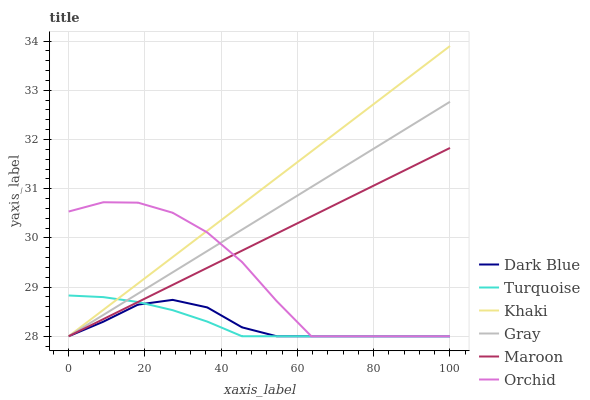Does Dark Blue have the minimum area under the curve?
Answer yes or no. Yes. Does Khaki have the maximum area under the curve?
Answer yes or no. Yes. Does Turquoise have the minimum area under the curve?
Answer yes or no. No. Does Turquoise have the maximum area under the curve?
Answer yes or no. No. Is Gray the smoothest?
Answer yes or no. Yes. Is Orchid the roughest?
Answer yes or no. Yes. Is Turquoise the smoothest?
Answer yes or no. No. Is Turquoise the roughest?
Answer yes or no. No. Does Gray have the lowest value?
Answer yes or no. Yes. Does Khaki have the highest value?
Answer yes or no. Yes. Does Turquoise have the highest value?
Answer yes or no. No. Does Dark Blue intersect Gray?
Answer yes or no. Yes. Is Dark Blue less than Gray?
Answer yes or no. No. Is Dark Blue greater than Gray?
Answer yes or no. No. 